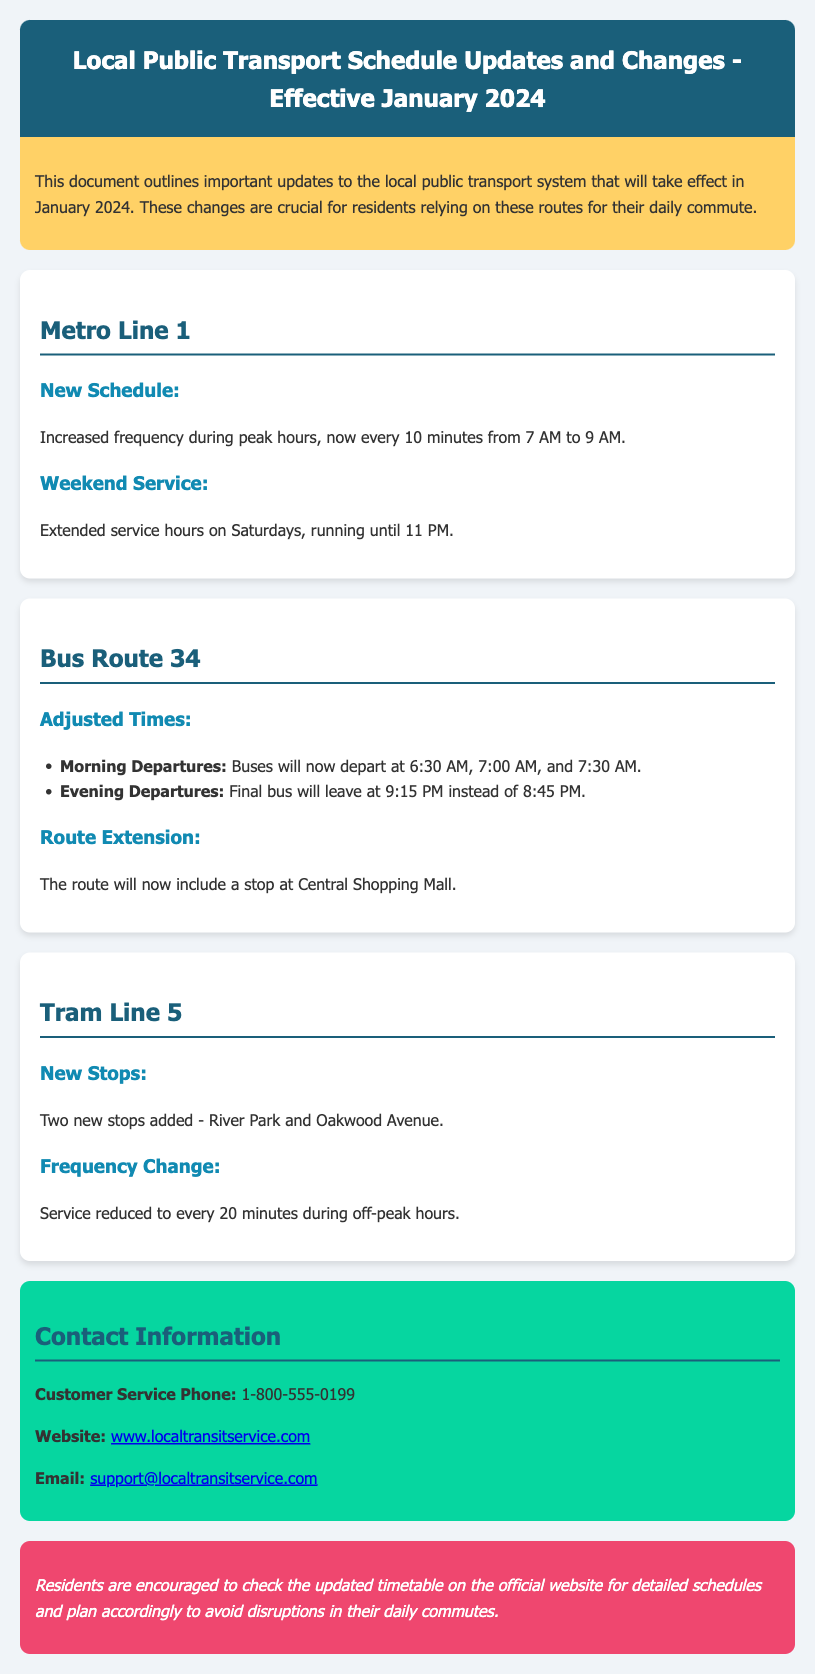What is the new frequency for Metro Line 1 during peak hours? The document states that the frequency will be every 10 minutes from 7 AM to 9 AM.
Answer: every 10 minutes What is the last bus departure time for Bus Route 34? The final bus will leave at 9:15 PM instead of 8:45 PM.
Answer: 9:15 PM What new stops have been added to Tram Line 5? The document mentions two new stops: River Park and Oakwood Avenue.
Answer: River Park and Oakwood Avenue When will the extended weekend service for Metro Line 1 operate until? The document specifies that service will run until 11 PM on Saturdays.
Answer: 11 PM How many morning departures does Bus Route 34 have? The document lists morning departures at 6:30 AM, 7:00 AM, and 7:30 AM, which totals to three departures.
Answer: three What is the customer service phone number? The document provides the customer service phone number as 1-800-555-0199.
Answer: 1-800-555-0199 What is the change in frequency for Tram Line 5 during off-peak hours? The service will be reduced to every 20 minutes during off-peak hours.
Answer: every 20 minutes What is the purpose of this document? The document outlines important updates to the local public transport system effective in January 2024, crucial for residents.
Answer: updates to local public transport 